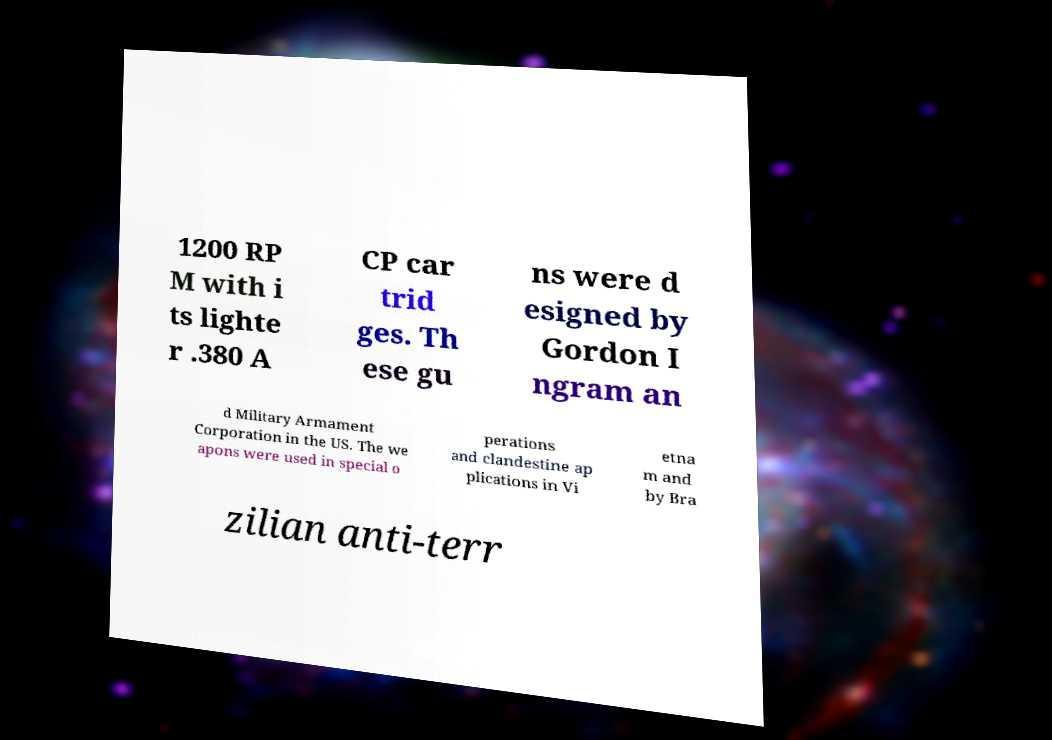Can you accurately transcribe the text from the provided image for me? 1200 RP M with i ts lighte r .380 A CP car trid ges. Th ese gu ns were d esigned by Gordon I ngram an d Military Armament Corporation in the US. The we apons were used in special o perations and clandestine ap plications in Vi etna m and by Bra zilian anti-terr 